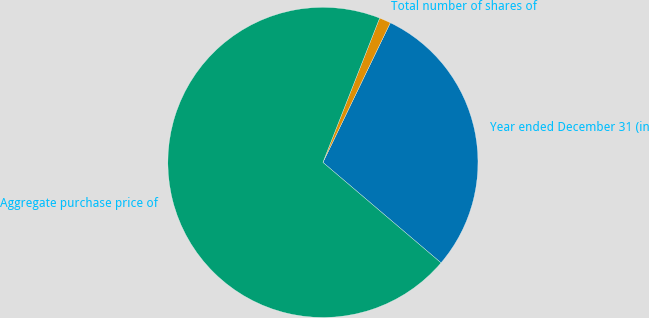Convert chart. <chart><loc_0><loc_0><loc_500><loc_500><pie_chart><fcel>Year ended December 31 (in<fcel>Total number of shares of<fcel>Aggregate purchase price of<nl><fcel>29.06%<fcel>1.2%<fcel>69.74%<nl></chart> 